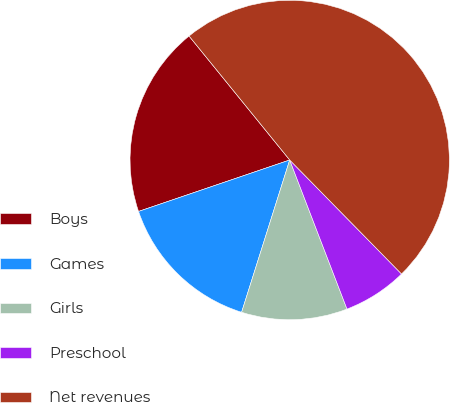Convert chart to OTSL. <chart><loc_0><loc_0><loc_500><loc_500><pie_chart><fcel>Boys<fcel>Games<fcel>Girls<fcel>Preschool<fcel>Net revenues<nl><fcel>19.37%<fcel>14.91%<fcel>10.71%<fcel>6.51%<fcel>48.51%<nl></chart> 